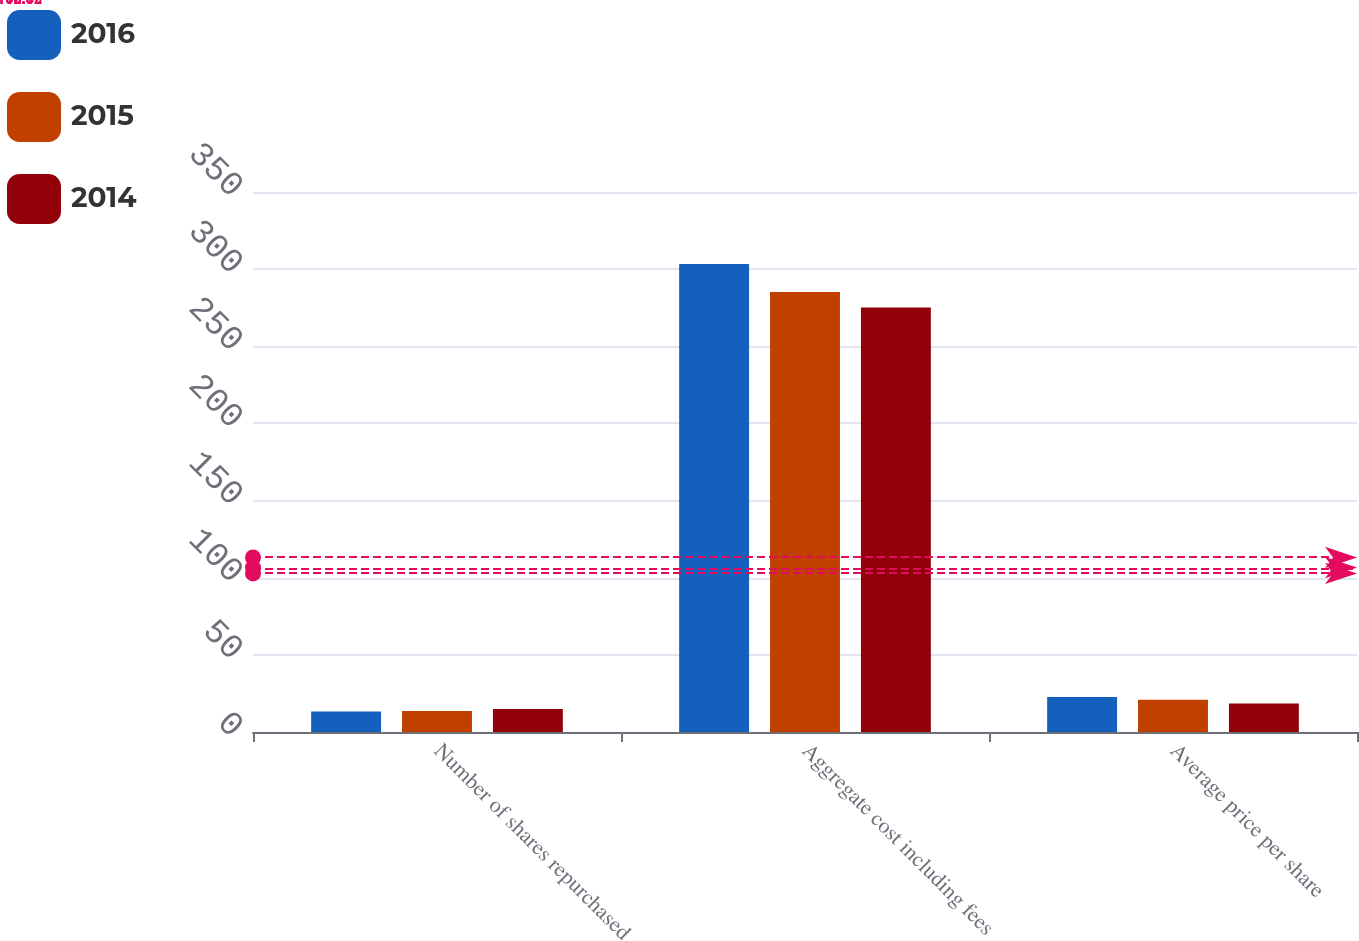Convert chart. <chart><loc_0><loc_0><loc_500><loc_500><stacked_bar_chart><ecel><fcel>Number of shares repurchased<fcel>Aggregate cost including fees<fcel>Average price per share<nl><fcel>2016<fcel>13.3<fcel>303.3<fcel>22.76<nl><fcel>2015<fcel>13.6<fcel>285.2<fcel>20.97<nl><fcel>2014<fcel>14.9<fcel>275.1<fcel>18.41<nl></chart> 